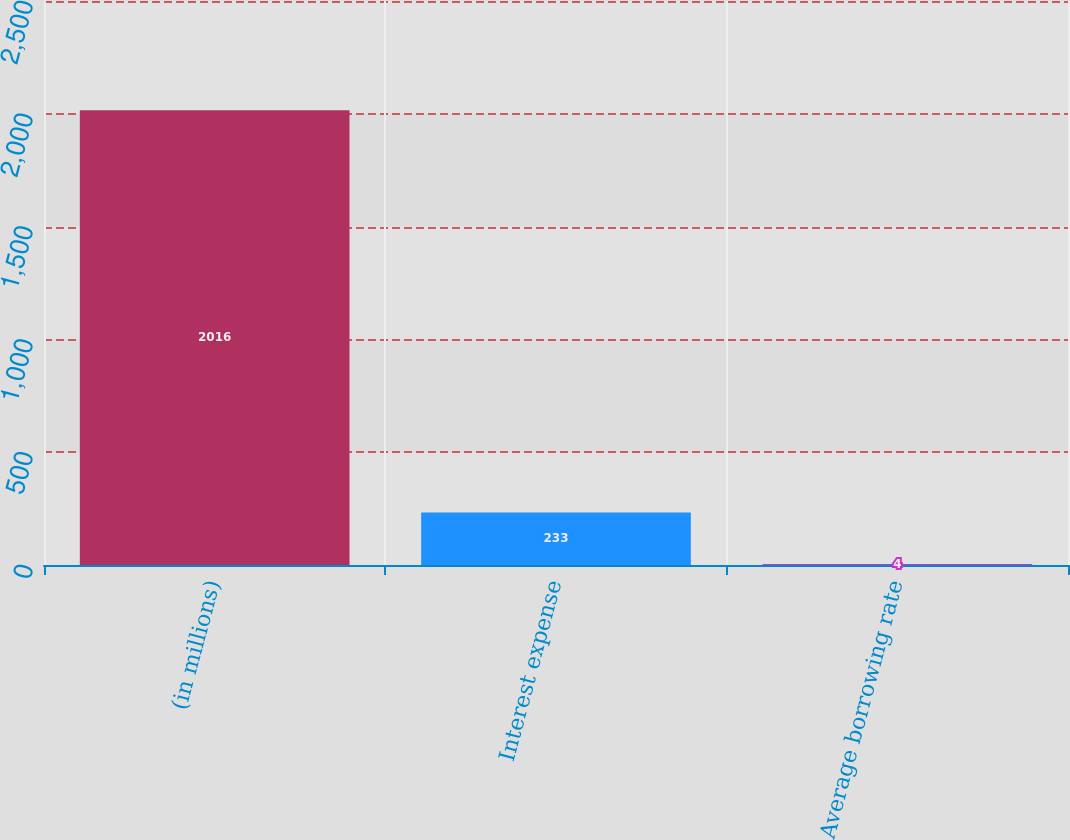<chart> <loc_0><loc_0><loc_500><loc_500><bar_chart><fcel>(in millions)<fcel>Interest expense<fcel>Average borrowing rate<nl><fcel>2016<fcel>233<fcel>4<nl></chart> 